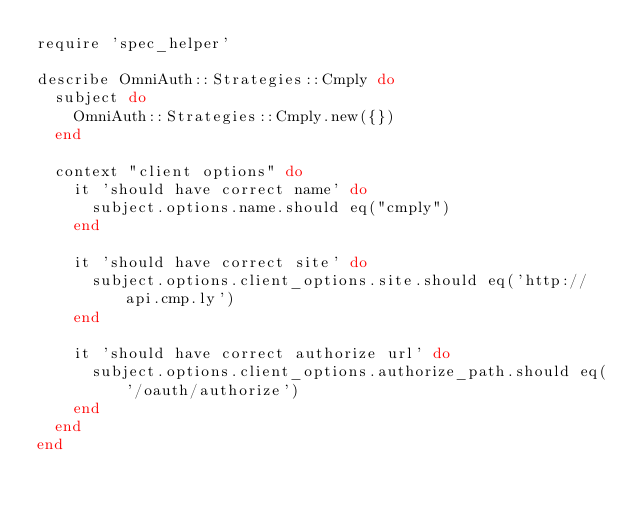<code> <loc_0><loc_0><loc_500><loc_500><_Ruby_>require 'spec_helper'

describe OmniAuth::Strategies::Cmply do
  subject do
    OmniAuth::Strategies::Cmply.new({})
  end

  context "client options" do
    it 'should have correct name' do
      subject.options.name.should eq("cmply")
    end

    it 'should have correct site' do
      subject.options.client_options.site.should eq('http://api.cmp.ly')
    end

    it 'should have correct authorize url' do
      subject.options.client_options.authorize_path.should eq('/oauth/authorize')
    end
  end
end
</code> 